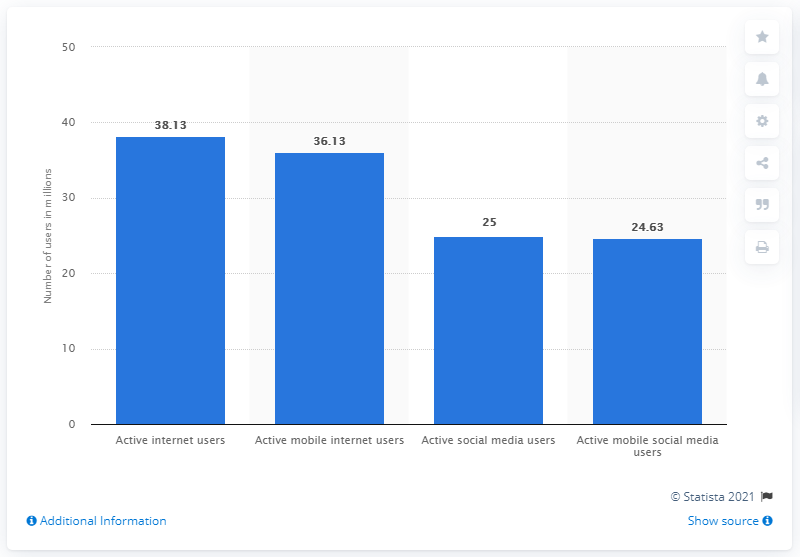Outline some significant characteristics in this image. As of January 2021, it is estimated that there were 38.13 million internet users in South Africa. According to a January 2021 report, 36.13% of South Africans used mobile internet. 